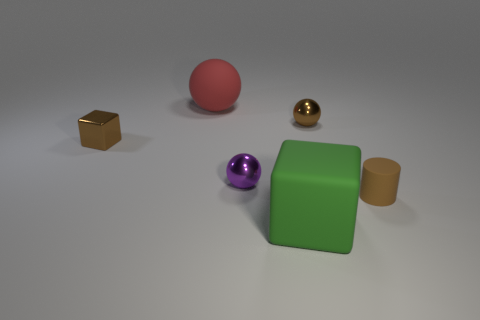Subtract all small purple spheres. How many spheres are left? 2 Add 1 small brown metal objects. How many objects exist? 7 Subtract all blue spheres. Subtract all green cylinders. How many spheres are left? 3 Subtract all cubes. How many objects are left? 4 Add 6 big yellow shiny objects. How many big yellow shiny objects exist? 6 Subtract 0 cyan cubes. How many objects are left? 6 Subtract all brown things. Subtract all blue shiny cylinders. How many objects are left? 3 Add 2 purple metal objects. How many purple metal objects are left? 3 